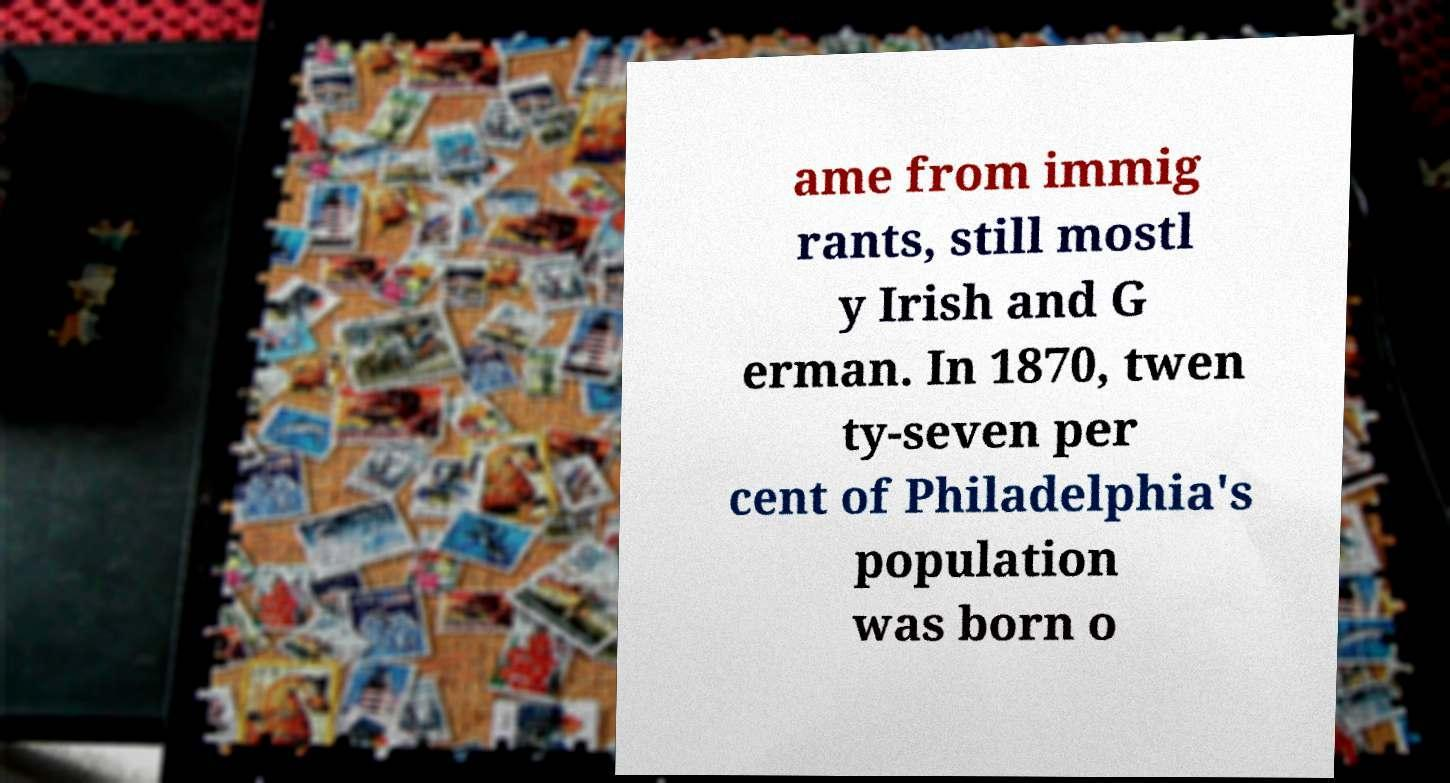Please identify and transcribe the text found in this image. ame from immig rants, still mostl y Irish and G erman. In 1870, twen ty-seven per cent of Philadelphia's population was born o 